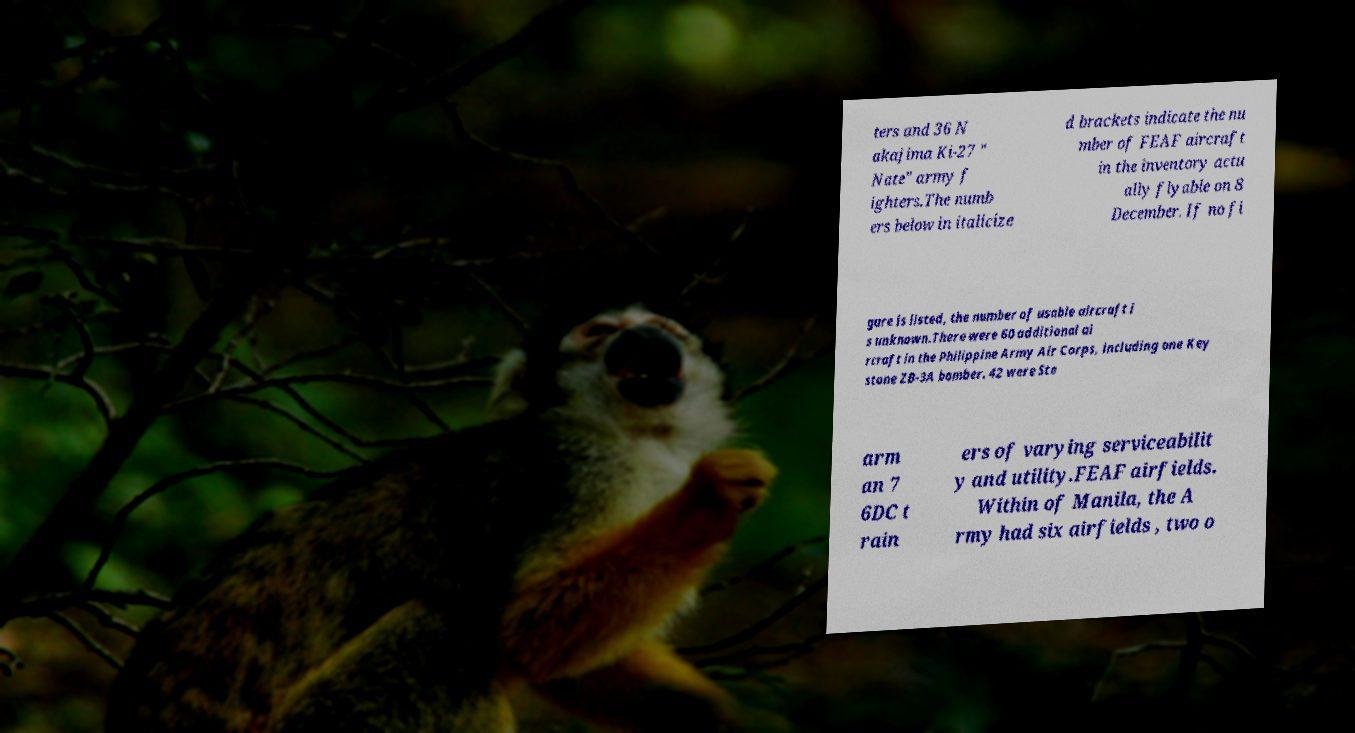There's text embedded in this image that I need extracted. Can you transcribe it verbatim? ters and 36 N akajima Ki-27 " Nate" army f ighters.The numb ers below in italicize d brackets indicate the nu mber of FEAF aircraft in the inventory actu ally flyable on 8 December. If no fi gure is listed, the number of usable aircraft i s unknown.There were 60 additional ai rcraft in the Philippine Army Air Corps, including one Key stone ZB-3A bomber. 42 were Ste arm an 7 6DC t rain ers of varying serviceabilit y and utility.FEAF airfields. Within of Manila, the A rmy had six airfields , two o 